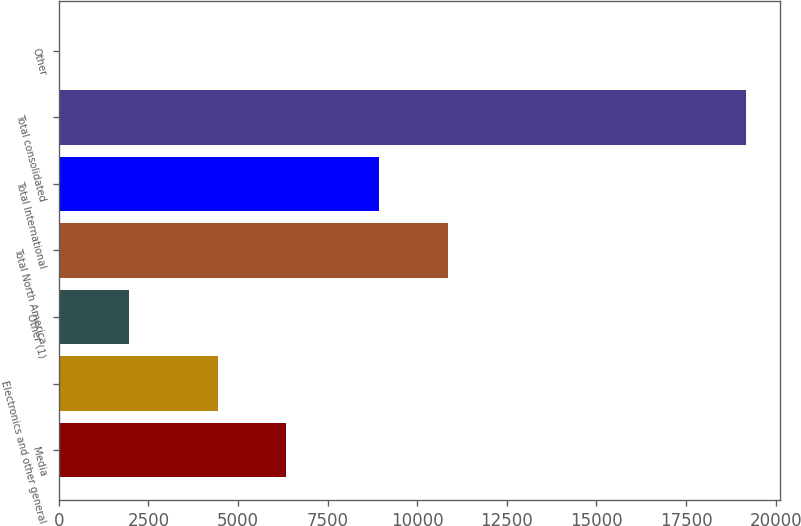Convert chart to OTSL. <chart><loc_0><loc_0><loc_500><loc_500><bar_chart><fcel>Media<fcel>Electronics and other general<fcel>Other (1)<fcel>Total North America<fcel>Total International<fcel>Total consolidated<fcel>Other<nl><fcel>6342.8<fcel>4430<fcel>1950.8<fcel>10850.8<fcel>8938<fcel>19166<fcel>38<nl></chart> 